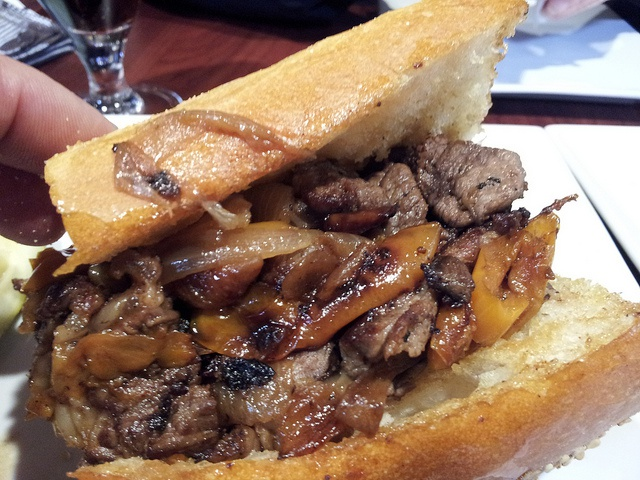Describe the objects in this image and their specific colors. I can see dining table in darkgray, maroon, black, white, and gray tones, sandwich in darkgray, maroon, black, tan, and gray tones, dining table in darkgray, maroon, black, and brown tones, people in darkgray, lightpink, maroon, black, and brown tones, and wine glass in darkgray, black, gray, and maroon tones in this image. 